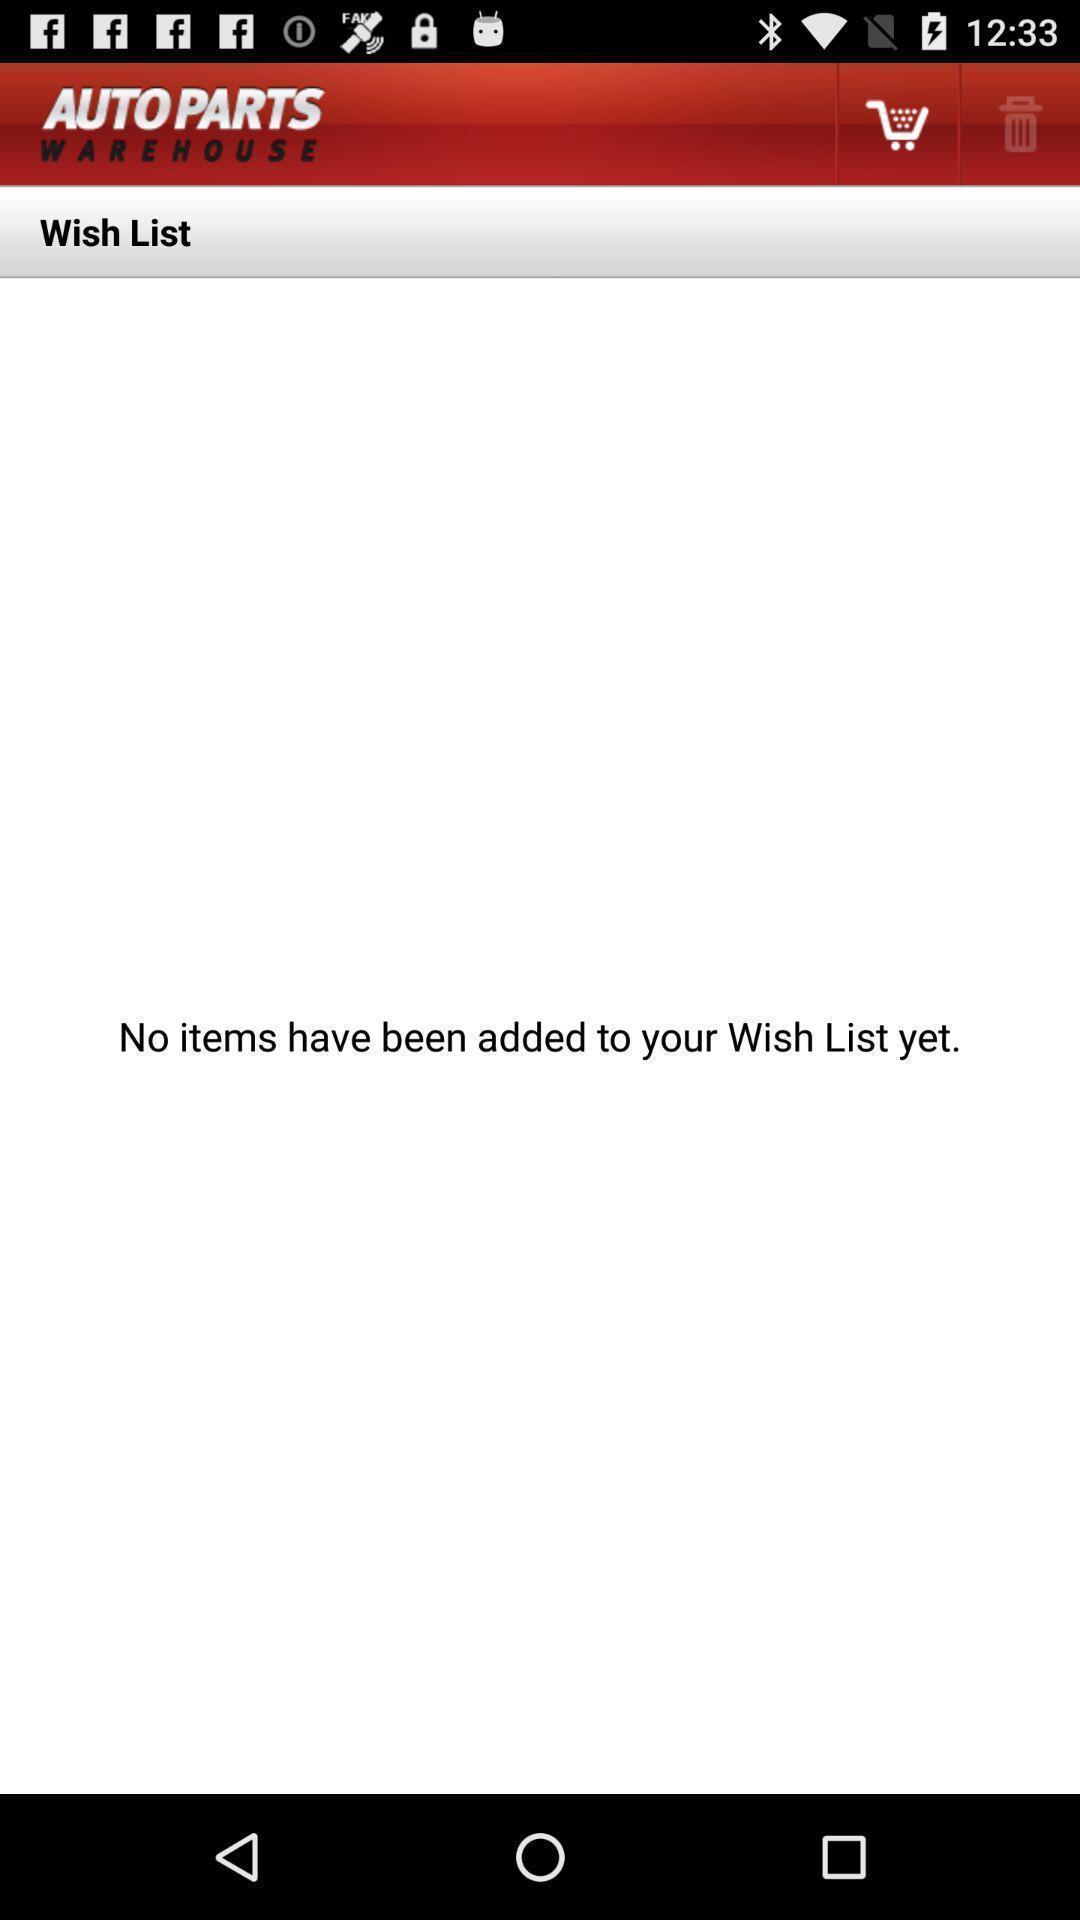Provide a description of this screenshot. Wish list page. 